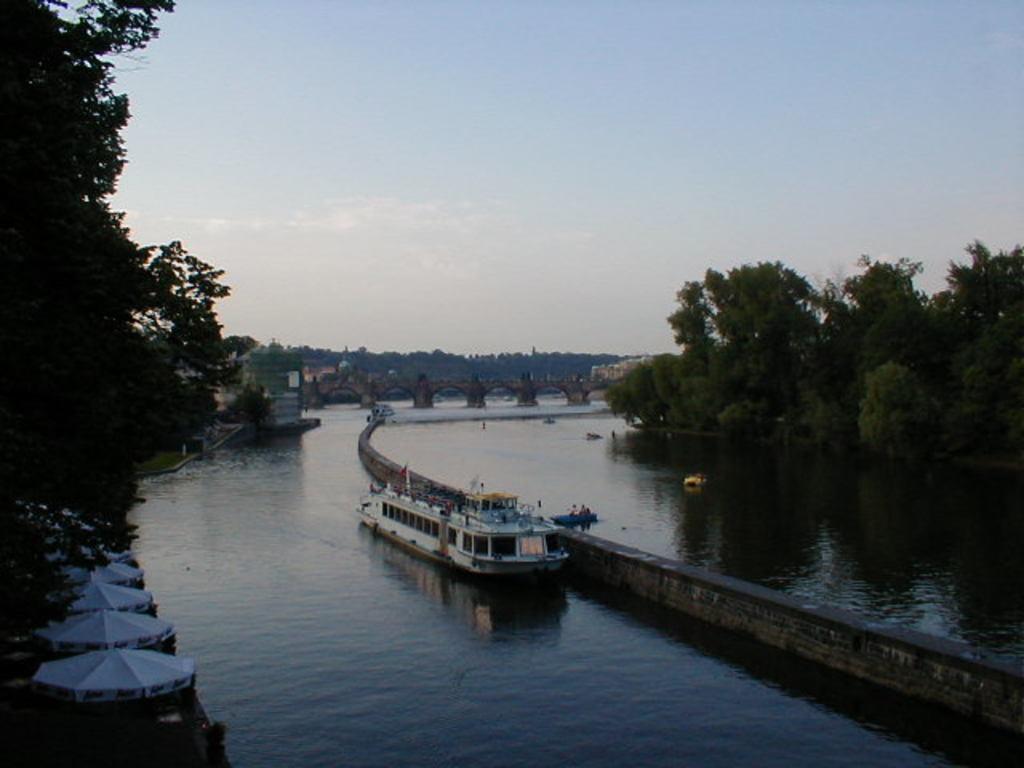Can you describe this image briefly? In this picture I can observe a boat floating on the water in the middle of the picture. On either sides of the river I can observe trees. In the background I can observe sky. 